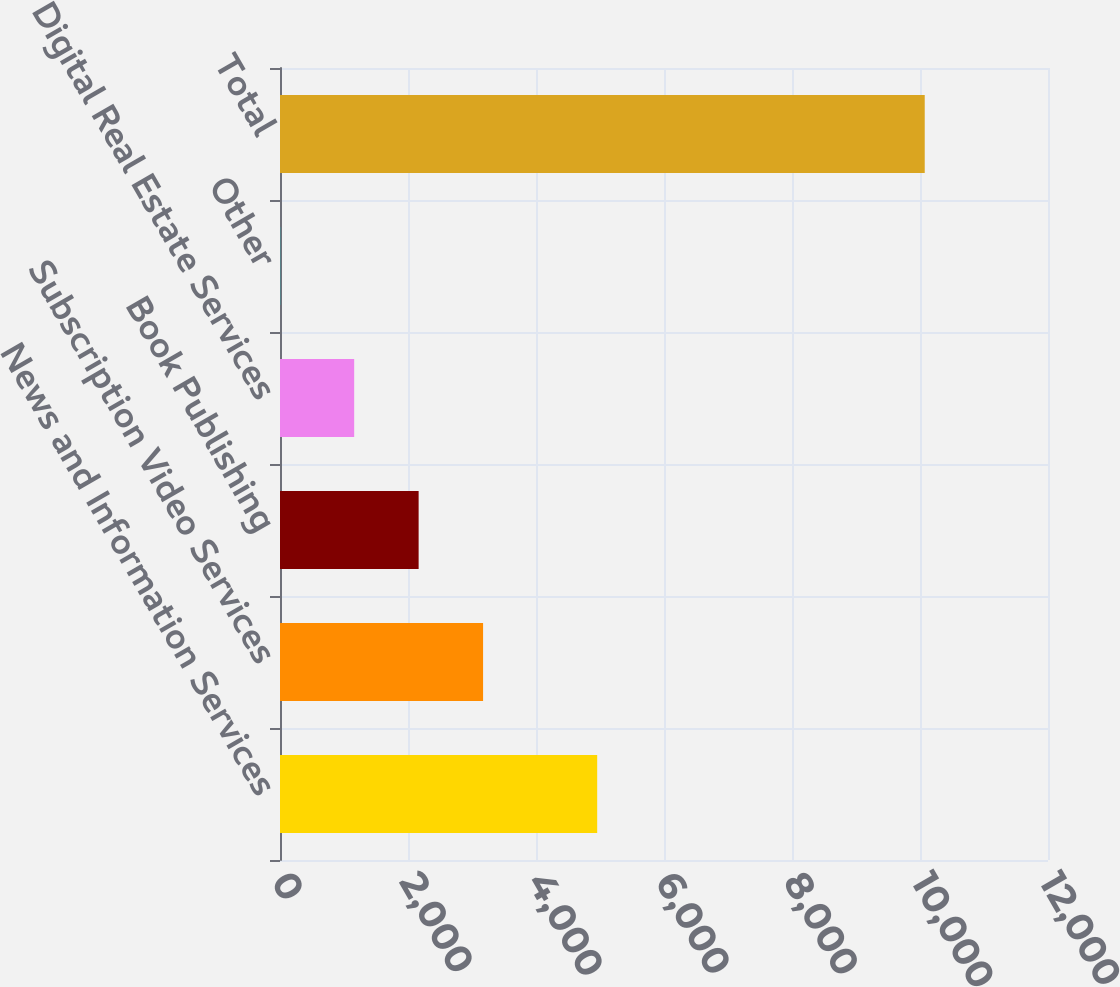Convert chart. <chart><loc_0><loc_0><loc_500><loc_500><bar_chart><fcel>News and Information Services<fcel>Subscription Video Services<fcel>Book Publishing<fcel>Digital Real Estate Services<fcel>Other<fcel>Total<nl><fcel>4956<fcel>3173.2<fcel>2166.1<fcel>1159<fcel>3<fcel>10074<nl></chart> 